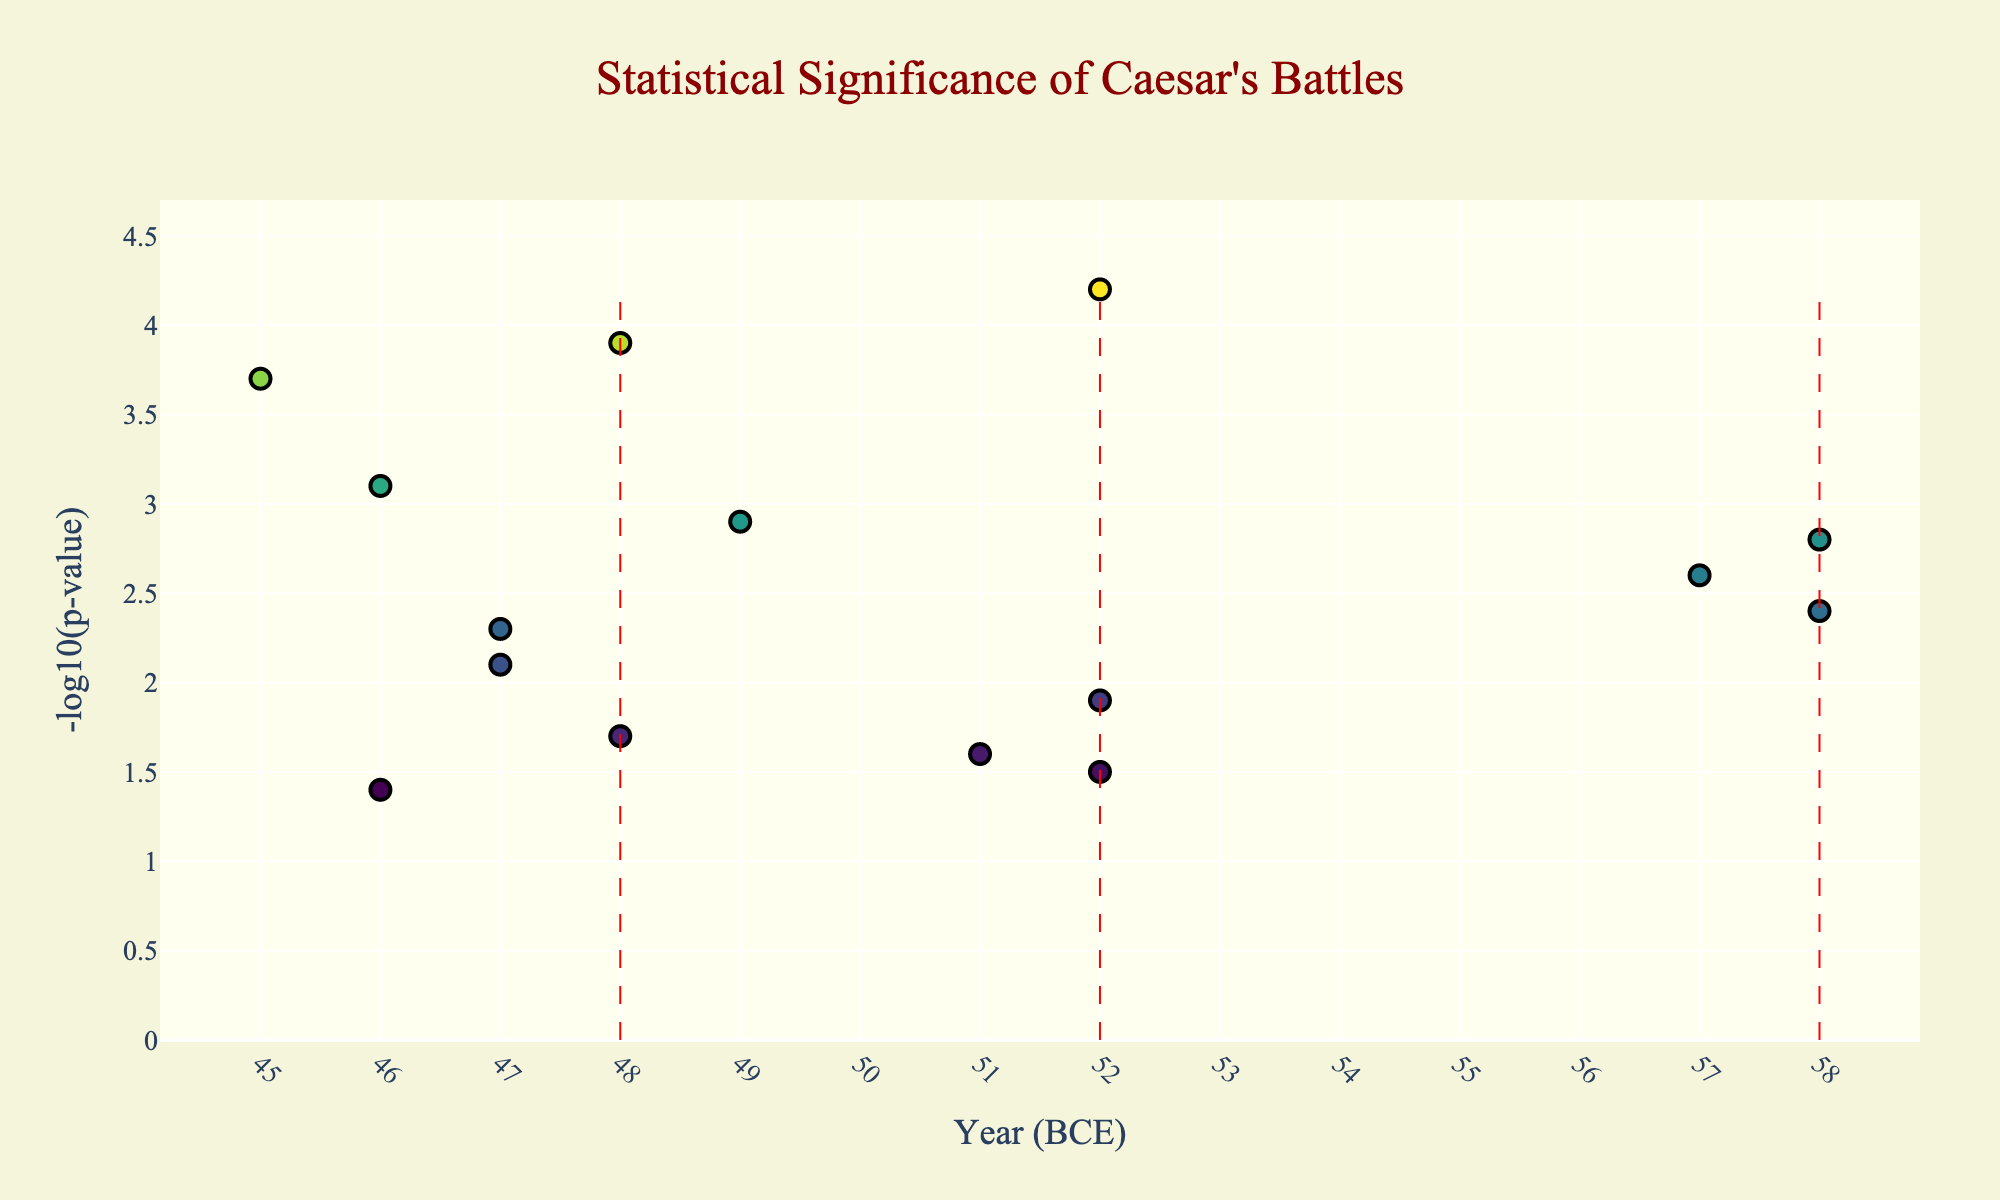What is the title of the plot? The title is located at the top center of the plot. It reads "Statistical Significance of Caesar's Battles" as extracted from the title tag in the plot layout section.
Answer: Statistical Significance of Caesar's Battles Which battle has the highest statistical significance? The battle with the highest -log10(p-value) represents the highest statistical significance. The plot shows Alesia with the maximum value of 4.2.
Answer: Alesia What is the y-axis title, and what does it represent? The y-axis title is given as "-log10(p-value)," which is a common measurement in statistical analysis to represent the significance of battles. Higher values indicate higher statistical significance.
Answer: -log10(p-value) Which battles took place in the year 52 BCE and what are their statistical significances? By observing the x-axis (Year) and hovering over the corresponding data points, we find that Gergovia, Alesia, and Avaricum took place in 52 BCE with -log10(p-values) of 1.5, 4.2, and 1.9, respectively.
Answer: Gergovia (1.5), Alesia (4.2), Avaricum (1.9) How many battles have a statistical significance greater than 3? Battles with -log10(p-values) greater than 3 are counted. The qualifying battles are Alesia (4.2), Pharsalus (3.9), Thapsus (3.1), and Munda (3.7), totaling 4.
Answer: 4 What is the average statistical significance of the battles that took place in 47 BCE? The -log10(p-values) for Alexandria and Zela in 47 BCE are 2.1 and 2.3. The average is calculated as (2.1 + 2.3) / 2 = 2.2.
Answer: 2.2 Which battle marked by data points has the lowest statistical significance, and what is that value? The lowest -log10(p-value) is found by observing the y-values, where Ruspina has the lowest value of 1.4.
Answer: Ruspina (1.4) Which year has the highest mean statistical significance among its battles? For each year, calculate the mean -log10(p-value) of all battles. 48 BCE has two battles (Pharsalus 3.9, Dyrrhachium 1.7) with a mean of (3.9 + 1.7)/2 = 2.8. Comparing other years, 48 BCE has the highest mean.
Answer: 48 BCE How does the statistical significance of Munda compare to that of Thapsus? The plot shows -log10(p-values) for Munda (3.7) and Thapsus (3.1). Munda has a higher statistical significance than Thapsus.
Answer: Munda > Thapsus What is the range of statistical significances observed across all the battles? The minimum statistical significance is 1.4 (Ruspina) and the maximum is 4.2 (Alesia). The range is calculated as 4.2 - 1.4 = 2.8.
Answer: 2.8 